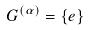<formula> <loc_0><loc_0><loc_500><loc_500>G ^ { ( \alpha ) } = \{ e \}</formula> 